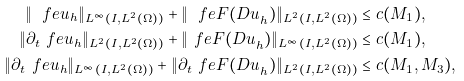Convert formula to latex. <formula><loc_0><loc_0><loc_500><loc_500>\| \ f e u _ { h } \| _ { L ^ { \infty } ( I , L ^ { 2 } ( \Omega ) ) } + \| \ f e { F ( D u } _ { h } ) \| _ { L ^ { 2 } ( I , L ^ { 2 } ( \Omega ) ) } & \leq c ( M _ { 1 } ) , \\ \| \partial _ { t } \ f e u _ { h } \| _ { L ^ { 2 } ( I , L ^ { 2 } ( \Omega ) ) } + \| \ f e { F ( D u } _ { h } ) \| _ { L ^ { \infty } ( I , L ^ { 2 } ( \Omega ) ) } & \leq c ( M _ { 1 } ) , \\ \| \partial _ { t } \ f e u _ { h } \| _ { L ^ { \infty } ( I , L ^ { 2 } ( \Omega ) ) } + \| \partial _ { t } \ f e { F ( D u } _ { h } ) \| _ { L ^ { 2 } ( I , L ^ { 2 } ( \Omega ) ) } & \leq c ( M _ { 1 } , M _ { 3 } ) ,</formula> 